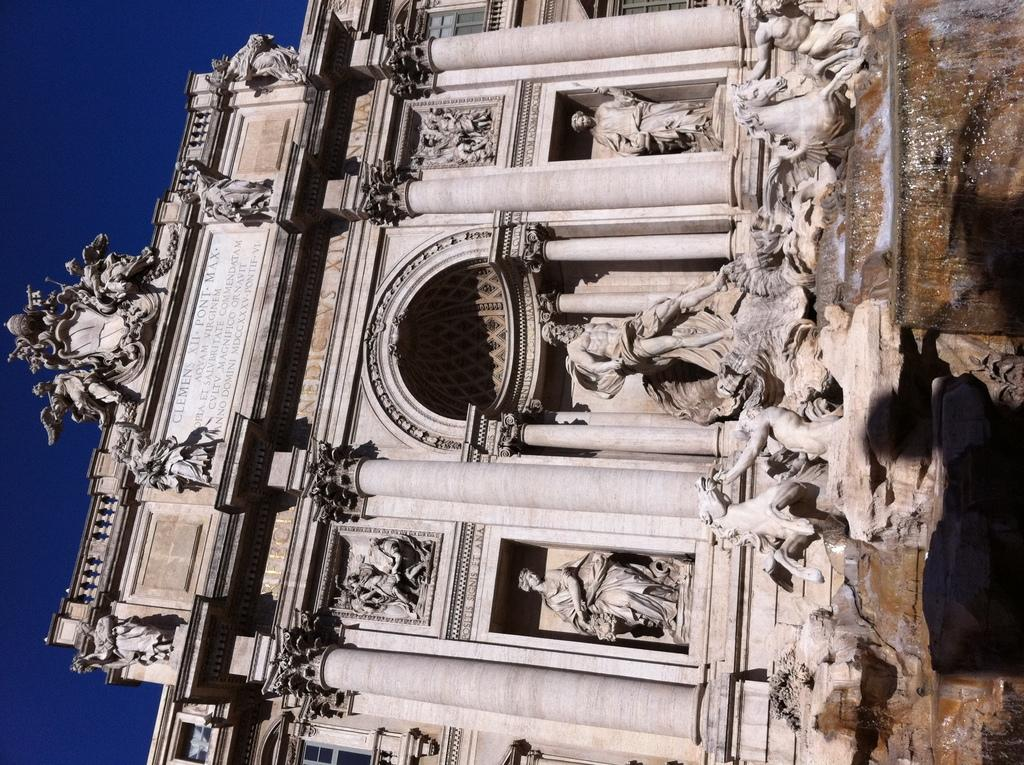What can be seen in the picture? There are sculptures in the picture. Where are the sculptures located? The sculptures are attached to a building. What type of bread can be seen in the picture? There is no bread present in the picture; it features sculptures attached to a building. How many snails are visible on the sculptures in the picture? There are no snails visible on the sculptures in the picture. 